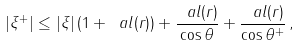Convert formula to latex. <formula><loc_0><loc_0><loc_500><loc_500>| \xi ^ { + } | \leq | \xi | \, ( 1 + \ a l ( r ) ) + \frac { \ a l ( r ) } { \cos \theta } + \frac { \ a l ( r ) } { \cos \theta ^ { + } } \, ,</formula> 